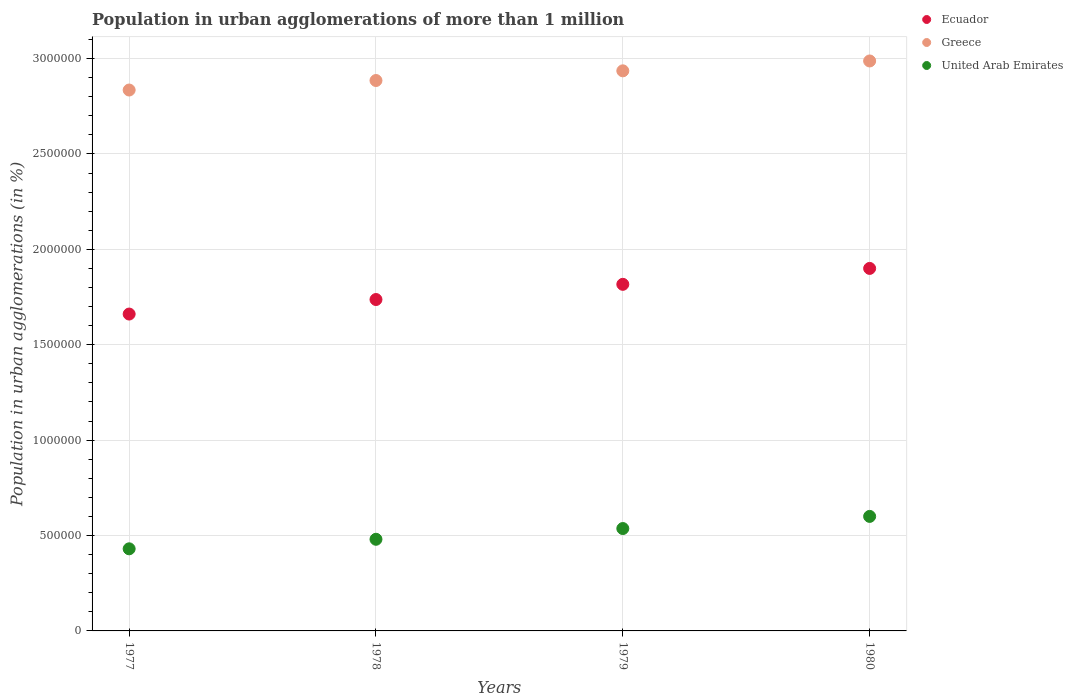What is the population in urban agglomerations in Greece in 1978?
Keep it short and to the point. 2.89e+06. Across all years, what is the maximum population in urban agglomerations in Greece?
Offer a terse response. 2.99e+06. Across all years, what is the minimum population in urban agglomerations in Greece?
Make the answer very short. 2.84e+06. What is the total population in urban agglomerations in Greece in the graph?
Make the answer very short. 1.16e+07. What is the difference between the population in urban agglomerations in Greece in 1979 and that in 1980?
Keep it short and to the point. -5.17e+04. What is the difference between the population in urban agglomerations in Ecuador in 1979 and the population in urban agglomerations in Greece in 1980?
Provide a succinct answer. -1.17e+06. What is the average population in urban agglomerations in Greece per year?
Offer a very short reply. 2.91e+06. In the year 1977, what is the difference between the population in urban agglomerations in Greece and population in urban agglomerations in United Arab Emirates?
Keep it short and to the point. 2.40e+06. What is the ratio of the population in urban agglomerations in Ecuador in 1977 to that in 1980?
Your answer should be very brief. 0.87. Is the population in urban agglomerations in United Arab Emirates in 1977 less than that in 1980?
Provide a succinct answer. Yes. Is the difference between the population in urban agglomerations in Greece in 1979 and 1980 greater than the difference between the population in urban agglomerations in United Arab Emirates in 1979 and 1980?
Your response must be concise. Yes. What is the difference between the highest and the second highest population in urban agglomerations in Greece?
Provide a succinct answer. 5.17e+04. What is the difference between the highest and the lowest population in urban agglomerations in United Arab Emirates?
Give a very brief answer. 1.70e+05. In how many years, is the population in urban agglomerations in Greece greater than the average population in urban agglomerations in Greece taken over all years?
Ensure brevity in your answer.  2. Does the population in urban agglomerations in United Arab Emirates monotonically increase over the years?
Your response must be concise. Yes. Is the population in urban agglomerations in Ecuador strictly greater than the population in urban agglomerations in Greece over the years?
Offer a terse response. No. How many dotlines are there?
Ensure brevity in your answer.  3. How many years are there in the graph?
Provide a short and direct response. 4. What is the difference between two consecutive major ticks on the Y-axis?
Provide a succinct answer. 5.00e+05. Does the graph contain any zero values?
Your answer should be compact. No. How are the legend labels stacked?
Your response must be concise. Vertical. What is the title of the graph?
Your answer should be compact. Population in urban agglomerations of more than 1 million. Does "Equatorial Guinea" appear as one of the legend labels in the graph?
Ensure brevity in your answer.  No. What is the label or title of the X-axis?
Your response must be concise. Years. What is the label or title of the Y-axis?
Provide a short and direct response. Population in urban agglomerations (in %). What is the Population in urban agglomerations (in %) of Ecuador in 1977?
Ensure brevity in your answer.  1.66e+06. What is the Population in urban agglomerations (in %) of Greece in 1977?
Provide a short and direct response. 2.84e+06. What is the Population in urban agglomerations (in %) in United Arab Emirates in 1977?
Provide a short and direct response. 4.30e+05. What is the Population in urban agglomerations (in %) in Ecuador in 1978?
Your answer should be very brief. 1.74e+06. What is the Population in urban agglomerations (in %) of Greece in 1978?
Offer a very short reply. 2.89e+06. What is the Population in urban agglomerations (in %) of United Arab Emirates in 1978?
Offer a terse response. 4.80e+05. What is the Population in urban agglomerations (in %) in Ecuador in 1979?
Your answer should be very brief. 1.82e+06. What is the Population in urban agglomerations (in %) of Greece in 1979?
Offer a very short reply. 2.94e+06. What is the Population in urban agglomerations (in %) of United Arab Emirates in 1979?
Provide a succinct answer. 5.37e+05. What is the Population in urban agglomerations (in %) of Ecuador in 1980?
Offer a terse response. 1.90e+06. What is the Population in urban agglomerations (in %) of Greece in 1980?
Give a very brief answer. 2.99e+06. What is the Population in urban agglomerations (in %) of United Arab Emirates in 1980?
Make the answer very short. 6.00e+05. Across all years, what is the maximum Population in urban agglomerations (in %) of Ecuador?
Your response must be concise. 1.90e+06. Across all years, what is the maximum Population in urban agglomerations (in %) in Greece?
Give a very brief answer. 2.99e+06. Across all years, what is the maximum Population in urban agglomerations (in %) in United Arab Emirates?
Your response must be concise. 6.00e+05. Across all years, what is the minimum Population in urban agglomerations (in %) in Ecuador?
Make the answer very short. 1.66e+06. Across all years, what is the minimum Population in urban agglomerations (in %) in Greece?
Provide a succinct answer. 2.84e+06. Across all years, what is the minimum Population in urban agglomerations (in %) of United Arab Emirates?
Offer a terse response. 4.30e+05. What is the total Population in urban agglomerations (in %) of Ecuador in the graph?
Give a very brief answer. 7.11e+06. What is the total Population in urban agglomerations (in %) of Greece in the graph?
Offer a very short reply. 1.16e+07. What is the total Population in urban agglomerations (in %) in United Arab Emirates in the graph?
Ensure brevity in your answer.  2.05e+06. What is the difference between the Population in urban agglomerations (in %) of Ecuador in 1977 and that in 1978?
Offer a terse response. -7.61e+04. What is the difference between the Population in urban agglomerations (in %) in Greece in 1977 and that in 1978?
Make the answer very short. -4.99e+04. What is the difference between the Population in urban agglomerations (in %) in United Arab Emirates in 1977 and that in 1978?
Keep it short and to the point. -5.00e+04. What is the difference between the Population in urban agglomerations (in %) of Ecuador in 1977 and that in 1979?
Offer a very short reply. -1.56e+05. What is the difference between the Population in urban agglomerations (in %) in Greece in 1977 and that in 1979?
Your answer should be compact. -1.01e+05. What is the difference between the Population in urban agglomerations (in %) in United Arab Emirates in 1977 and that in 1979?
Provide a short and direct response. -1.06e+05. What is the difference between the Population in urban agglomerations (in %) of Ecuador in 1977 and that in 1980?
Offer a terse response. -2.39e+05. What is the difference between the Population in urban agglomerations (in %) of Greece in 1977 and that in 1980?
Provide a short and direct response. -1.52e+05. What is the difference between the Population in urban agglomerations (in %) in United Arab Emirates in 1977 and that in 1980?
Offer a terse response. -1.70e+05. What is the difference between the Population in urban agglomerations (in %) of Ecuador in 1978 and that in 1979?
Offer a terse response. -7.96e+04. What is the difference between the Population in urban agglomerations (in %) of Greece in 1978 and that in 1979?
Make the answer very short. -5.07e+04. What is the difference between the Population in urban agglomerations (in %) of United Arab Emirates in 1978 and that in 1979?
Ensure brevity in your answer.  -5.63e+04. What is the difference between the Population in urban agglomerations (in %) in Ecuador in 1978 and that in 1980?
Ensure brevity in your answer.  -1.63e+05. What is the difference between the Population in urban agglomerations (in %) of Greece in 1978 and that in 1980?
Your answer should be compact. -1.02e+05. What is the difference between the Population in urban agglomerations (in %) of United Arab Emirates in 1978 and that in 1980?
Offer a terse response. -1.20e+05. What is the difference between the Population in urban agglomerations (in %) of Ecuador in 1979 and that in 1980?
Offer a very short reply. -8.34e+04. What is the difference between the Population in urban agglomerations (in %) in Greece in 1979 and that in 1980?
Give a very brief answer. -5.17e+04. What is the difference between the Population in urban agglomerations (in %) in United Arab Emirates in 1979 and that in 1980?
Your response must be concise. -6.36e+04. What is the difference between the Population in urban agglomerations (in %) of Ecuador in 1977 and the Population in urban agglomerations (in %) of Greece in 1978?
Your response must be concise. -1.22e+06. What is the difference between the Population in urban agglomerations (in %) of Ecuador in 1977 and the Population in urban agglomerations (in %) of United Arab Emirates in 1978?
Keep it short and to the point. 1.18e+06. What is the difference between the Population in urban agglomerations (in %) of Greece in 1977 and the Population in urban agglomerations (in %) of United Arab Emirates in 1978?
Your answer should be very brief. 2.35e+06. What is the difference between the Population in urban agglomerations (in %) in Ecuador in 1977 and the Population in urban agglomerations (in %) in Greece in 1979?
Give a very brief answer. -1.27e+06. What is the difference between the Population in urban agglomerations (in %) in Ecuador in 1977 and the Population in urban agglomerations (in %) in United Arab Emirates in 1979?
Offer a very short reply. 1.12e+06. What is the difference between the Population in urban agglomerations (in %) of Greece in 1977 and the Population in urban agglomerations (in %) of United Arab Emirates in 1979?
Offer a very short reply. 2.30e+06. What is the difference between the Population in urban agglomerations (in %) of Ecuador in 1977 and the Population in urban agglomerations (in %) of Greece in 1980?
Make the answer very short. -1.33e+06. What is the difference between the Population in urban agglomerations (in %) in Ecuador in 1977 and the Population in urban agglomerations (in %) in United Arab Emirates in 1980?
Give a very brief answer. 1.06e+06. What is the difference between the Population in urban agglomerations (in %) of Greece in 1977 and the Population in urban agglomerations (in %) of United Arab Emirates in 1980?
Offer a terse response. 2.23e+06. What is the difference between the Population in urban agglomerations (in %) in Ecuador in 1978 and the Population in urban agglomerations (in %) in Greece in 1979?
Your answer should be very brief. -1.20e+06. What is the difference between the Population in urban agglomerations (in %) in Ecuador in 1978 and the Population in urban agglomerations (in %) in United Arab Emirates in 1979?
Make the answer very short. 1.20e+06. What is the difference between the Population in urban agglomerations (in %) of Greece in 1978 and the Population in urban agglomerations (in %) of United Arab Emirates in 1979?
Give a very brief answer. 2.35e+06. What is the difference between the Population in urban agglomerations (in %) of Ecuador in 1978 and the Population in urban agglomerations (in %) of Greece in 1980?
Your answer should be compact. -1.25e+06. What is the difference between the Population in urban agglomerations (in %) in Ecuador in 1978 and the Population in urban agglomerations (in %) in United Arab Emirates in 1980?
Ensure brevity in your answer.  1.14e+06. What is the difference between the Population in urban agglomerations (in %) of Greece in 1978 and the Population in urban agglomerations (in %) of United Arab Emirates in 1980?
Give a very brief answer. 2.28e+06. What is the difference between the Population in urban agglomerations (in %) of Ecuador in 1979 and the Population in urban agglomerations (in %) of Greece in 1980?
Your answer should be compact. -1.17e+06. What is the difference between the Population in urban agglomerations (in %) in Ecuador in 1979 and the Population in urban agglomerations (in %) in United Arab Emirates in 1980?
Offer a very short reply. 1.22e+06. What is the difference between the Population in urban agglomerations (in %) of Greece in 1979 and the Population in urban agglomerations (in %) of United Arab Emirates in 1980?
Provide a short and direct response. 2.34e+06. What is the average Population in urban agglomerations (in %) in Ecuador per year?
Your response must be concise. 1.78e+06. What is the average Population in urban agglomerations (in %) of Greece per year?
Ensure brevity in your answer.  2.91e+06. What is the average Population in urban agglomerations (in %) of United Arab Emirates per year?
Your answer should be compact. 5.12e+05. In the year 1977, what is the difference between the Population in urban agglomerations (in %) in Ecuador and Population in urban agglomerations (in %) in Greece?
Offer a very short reply. -1.17e+06. In the year 1977, what is the difference between the Population in urban agglomerations (in %) of Ecuador and Population in urban agglomerations (in %) of United Arab Emirates?
Provide a succinct answer. 1.23e+06. In the year 1977, what is the difference between the Population in urban agglomerations (in %) in Greece and Population in urban agglomerations (in %) in United Arab Emirates?
Your answer should be very brief. 2.40e+06. In the year 1978, what is the difference between the Population in urban agglomerations (in %) in Ecuador and Population in urban agglomerations (in %) in Greece?
Keep it short and to the point. -1.15e+06. In the year 1978, what is the difference between the Population in urban agglomerations (in %) in Ecuador and Population in urban agglomerations (in %) in United Arab Emirates?
Your answer should be very brief. 1.26e+06. In the year 1978, what is the difference between the Population in urban agglomerations (in %) in Greece and Population in urban agglomerations (in %) in United Arab Emirates?
Make the answer very short. 2.40e+06. In the year 1979, what is the difference between the Population in urban agglomerations (in %) in Ecuador and Population in urban agglomerations (in %) in Greece?
Offer a terse response. -1.12e+06. In the year 1979, what is the difference between the Population in urban agglomerations (in %) of Ecuador and Population in urban agglomerations (in %) of United Arab Emirates?
Offer a terse response. 1.28e+06. In the year 1979, what is the difference between the Population in urban agglomerations (in %) in Greece and Population in urban agglomerations (in %) in United Arab Emirates?
Keep it short and to the point. 2.40e+06. In the year 1980, what is the difference between the Population in urban agglomerations (in %) in Ecuador and Population in urban agglomerations (in %) in Greece?
Your answer should be compact. -1.09e+06. In the year 1980, what is the difference between the Population in urban agglomerations (in %) of Ecuador and Population in urban agglomerations (in %) of United Arab Emirates?
Provide a short and direct response. 1.30e+06. In the year 1980, what is the difference between the Population in urban agglomerations (in %) in Greece and Population in urban agglomerations (in %) in United Arab Emirates?
Provide a succinct answer. 2.39e+06. What is the ratio of the Population in urban agglomerations (in %) in Ecuador in 1977 to that in 1978?
Offer a terse response. 0.96. What is the ratio of the Population in urban agglomerations (in %) of Greece in 1977 to that in 1978?
Ensure brevity in your answer.  0.98. What is the ratio of the Population in urban agglomerations (in %) in United Arab Emirates in 1977 to that in 1978?
Keep it short and to the point. 0.9. What is the ratio of the Population in urban agglomerations (in %) of Ecuador in 1977 to that in 1979?
Give a very brief answer. 0.91. What is the ratio of the Population in urban agglomerations (in %) of Greece in 1977 to that in 1979?
Keep it short and to the point. 0.97. What is the ratio of the Population in urban agglomerations (in %) in United Arab Emirates in 1977 to that in 1979?
Keep it short and to the point. 0.8. What is the ratio of the Population in urban agglomerations (in %) of Ecuador in 1977 to that in 1980?
Provide a succinct answer. 0.87. What is the ratio of the Population in urban agglomerations (in %) of Greece in 1977 to that in 1980?
Provide a short and direct response. 0.95. What is the ratio of the Population in urban agglomerations (in %) in United Arab Emirates in 1977 to that in 1980?
Your answer should be compact. 0.72. What is the ratio of the Population in urban agglomerations (in %) of Ecuador in 1978 to that in 1979?
Provide a succinct answer. 0.96. What is the ratio of the Population in urban agglomerations (in %) in Greece in 1978 to that in 1979?
Ensure brevity in your answer.  0.98. What is the ratio of the Population in urban agglomerations (in %) in United Arab Emirates in 1978 to that in 1979?
Give a very brief answer. 0.9. What is the ratio of the Population in urban agglomerations (in %) of Ecuador in 1978 to that in 1980?
Your answer should be compact. 0.91. What is the ratio of the Population in urban agglomerations (in %) in Greece in 1978 to that in 1980?
Provide a short and direct response. 0.97. What is the ratio of the Population in urban agglomerations (in %) of United Arab Emirates in 1978 to that in 1980?
Your answer should be very brief. 0.8. What is the ratio of the Population in urban agglomerations (in %) in Ecuador in 1979 to that in 1980?
Offer a terse response. 0.96. What is the ratio of the Population in urban agglomerations (in %) of Greece in 1979 to that in 1980?
Your answer should be compact. 0.98. What is the ratio of the Population in urban agglomerations (in %) in United Arab Emirates in 1979 to that in 1980?
Provide a short and direct response. 0.89. What is the difference between the highest and the second highest Population in urban agglomerations (in %) in Ecuador?
Your response must be concise. 8.34e+04. What is the difference between the highest and the second highest Population in urban agglomerations (in %) in Greece?
Your response must be concise. 5.17e+04. What is the difference between the highest and the second highest Population in urban agglomerations (in %) of United Arab Emirates?
Provide a succinct answer. 6.36e+04. What is the difference between the highest and the lowest Population in urban agglomerations (in %) of Ecuador?
Make the answer very short. 2.39e+05. What is the difference between the highest and the lowest Population in urban agglomerations (in %) in Greece?
Keep it short and to the point. 1.52e+05. What is the difference between the highest and the lowest Population in urban agglomerations (in %) in United Arab Emirates?
Give a very brief answer. 1.70e+05. 